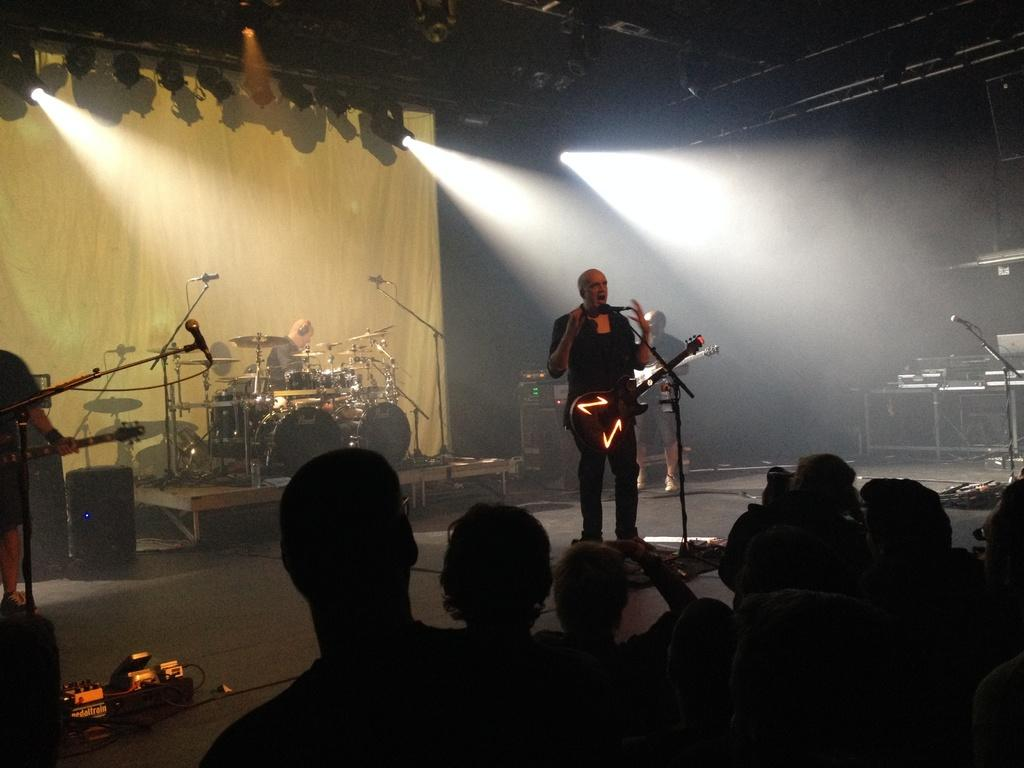What is the man in the image doing? The man is playing the guitar. What object is the man holding in the image? The man is holding a guitar. What can be seen behind the man in the image? There are musical instruments behind the man. What is the position of the people in relation to the man in the image? There are people in front of the man. What type of string can be seen in the image? There is no string present in the image. Can you see any sea creatures in the image? There are no sea creatures present in the image. 